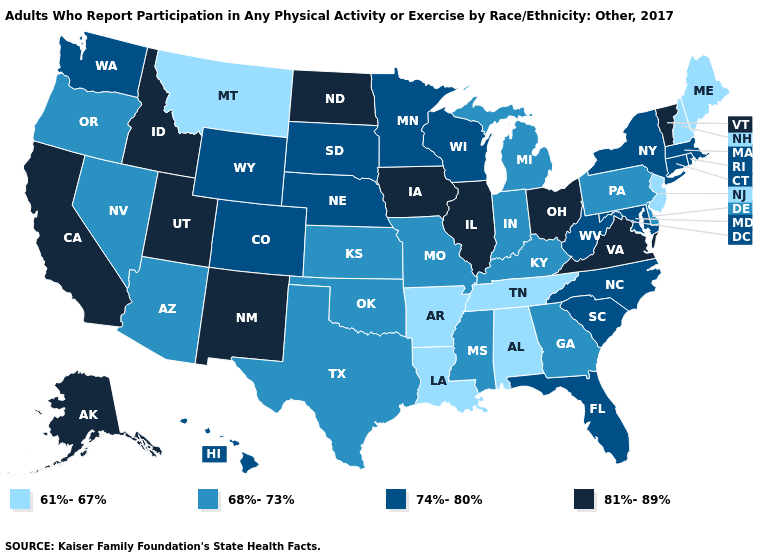What is the value of Arkansas?
Write a very short answer. 61%-67%. Name the states that have a value in the range 81%-89%?
Concise answer only. Alaska, California, Idaho, Illinois, Iowa, New Mexico, North Dakota, Ohio, Utah, Vermont, Virginia. Which states hav the highest value in the Northeast?
Answer briefly. Vermont. Which states hav the highest value in the Northeast?
Be succinct. Vermont. Name the states that have a value in the range 74%-80%?
Concise answer only. Colorado, Connecticut, Florida, Hawaii, Maryland, Massachusetts, Minnesota, Nebraska, New York, North Carolina, Rhode Island, South Carolina, South Dakota, Washington, West Virginia, Wisconsin, Wyoming. Among the states that border Kansas , does Colorado have the highest value?
Answer briefly. Yes. What is the lowest value in the West?
Give a very brief answer. 61%-67%. Which states hav the highest value in the South?
Short answer required. Virginia. What is the value of New Hampshire?
Quick response, please. 61%-67%. What is the lowest value in the USA?
Keep it brief. 61%-67%. Does the first symbol in the legend represent the smallest category?
Give a very brief answer. Yes. Does Vermont have a lower value than Colorado?
Keep it brief. No. What is the value of South Dakota?
Short answer required. 74%-80%. Does the map have missing data?
Write a very short answer. No. Which states hav the highest value in the South?
Concise answer only. Virginia. 